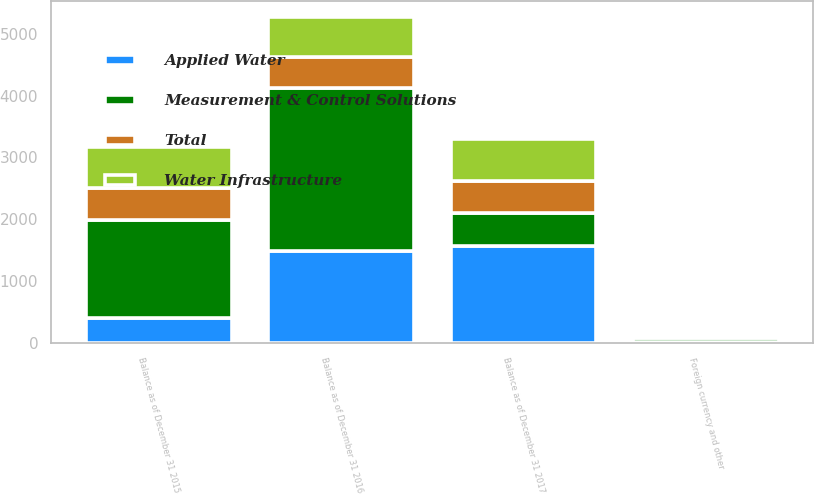Convert chart. <chart><loc_0><loc_0><loc_500><loc_500><stacked_bar_chart><ecel><fcel>Balance as of December 31 2015<fcel>Foreign currency and other<fcel>Balance as of December 31 2016<fcel>Balance as of December 31 2017<nl><fcel>Water Infrastructure<fcel>660<fcel>20<fcel>640<fcel>667<nl><fcel>Total<fcel>518<fcel>13<fcel>505<fcel>526<nl><fcel>Applied Water<fcel>406<fcel>25<fcel>1487<fcel>1575<nl><fcel>Measurement & Control Solutions<fcel>1584<fcel>58<fcel>2632<fcel>526<nl></chart> 